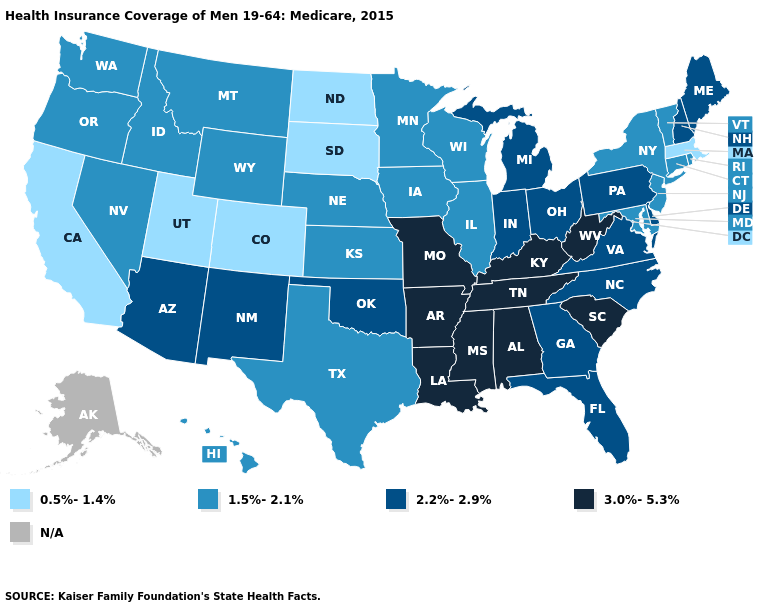Does the first symbol in the legend represent the smallest category?
Write a very short answer. Yes. Among the states that border Maryland , which have the highest value?
Answer briefly. West Virginia. Among the states that border New York , does Pennsylvania have the highest value?
Quick response, please. Yes. Does the first symbol in the legend represent the smallest category?
Answer briefly. Yes. Among the states that border South Dakota , which have the highest value?
Keep it brief. Iowa, Minnesota, Montana, Nebraska, Wyoming. Name the states that have a value in the range 2.2%-2.9%?
Concise answer only. Arizona, Delaware, Florida, Georgia, Indiana, Maine, Michigan, New Hampshire, New Mexico, North Carolina, Ohio, Oklahoma, Pennsylvania, Virginia. Does the map have missing data?
Concise answer only. Yes. Does Mississippi have the highest value in the USA?
Short answer required. Yes. Name the states that have a value in the range 2.2%-2.9%?
Concise answer only. Arizona, Delaware, Florida, Georgia, Indiana, Maine, Michigan, New Hampshire, New Mexico, North Carolina, Ohio, Oklahoma, Pennsylvania, Virginia. Name the states that have a value in the range 1.5%-2.1%?
Write a very short answer. Connecticut, Hawaii, Idaho, Illinois, Iowa, Kansas, Maryland, Minnesota, Montana, Nebraska, Nevada, New Jersey, New York, Oregon, Rhode Island, Texas, Vermont, Washington, Wisconsin, Wyoming. What is the value of South Dakota?
Be succinct. 0.5%-1.4%. What is the value of Texas?
Quick response, please. 1.5%-2.1%. Name the states that have a value in the range 0.5%-1.4%?
Give a very brief answer. California, Colorado, Massachusetts, North Dakota, South Dakota, Utah. Among the states that border Vermont , does New Hampshire have the lowest value?
Concise answer only. No. 